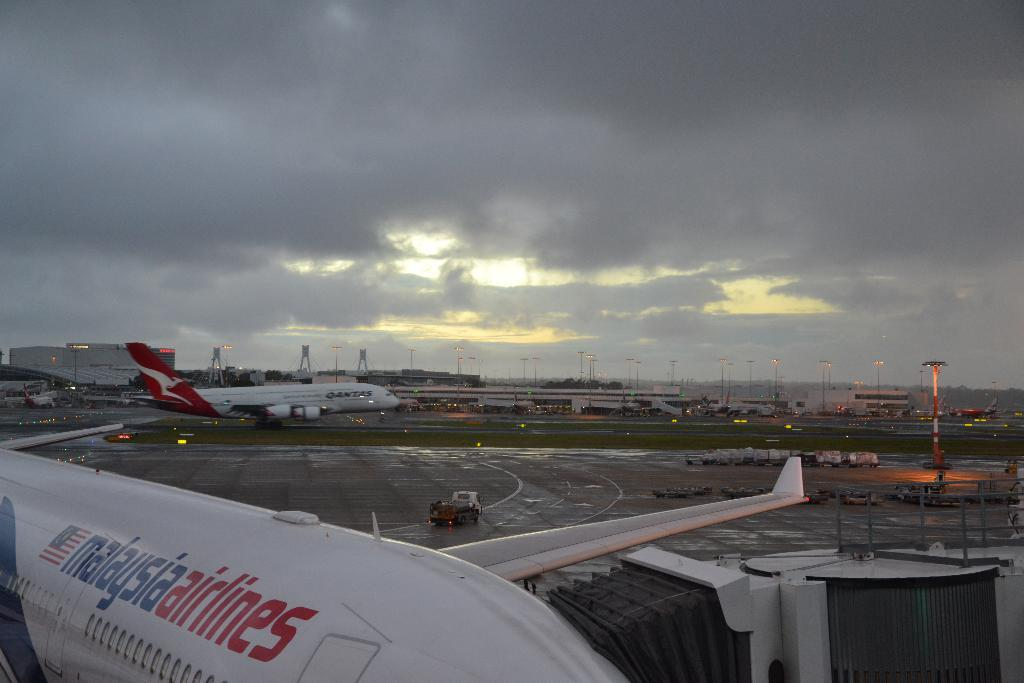<image>
Create a compact narrative representing the image presented. A Malaysia Airlines plane on a runway with a Qantas plane behind it 